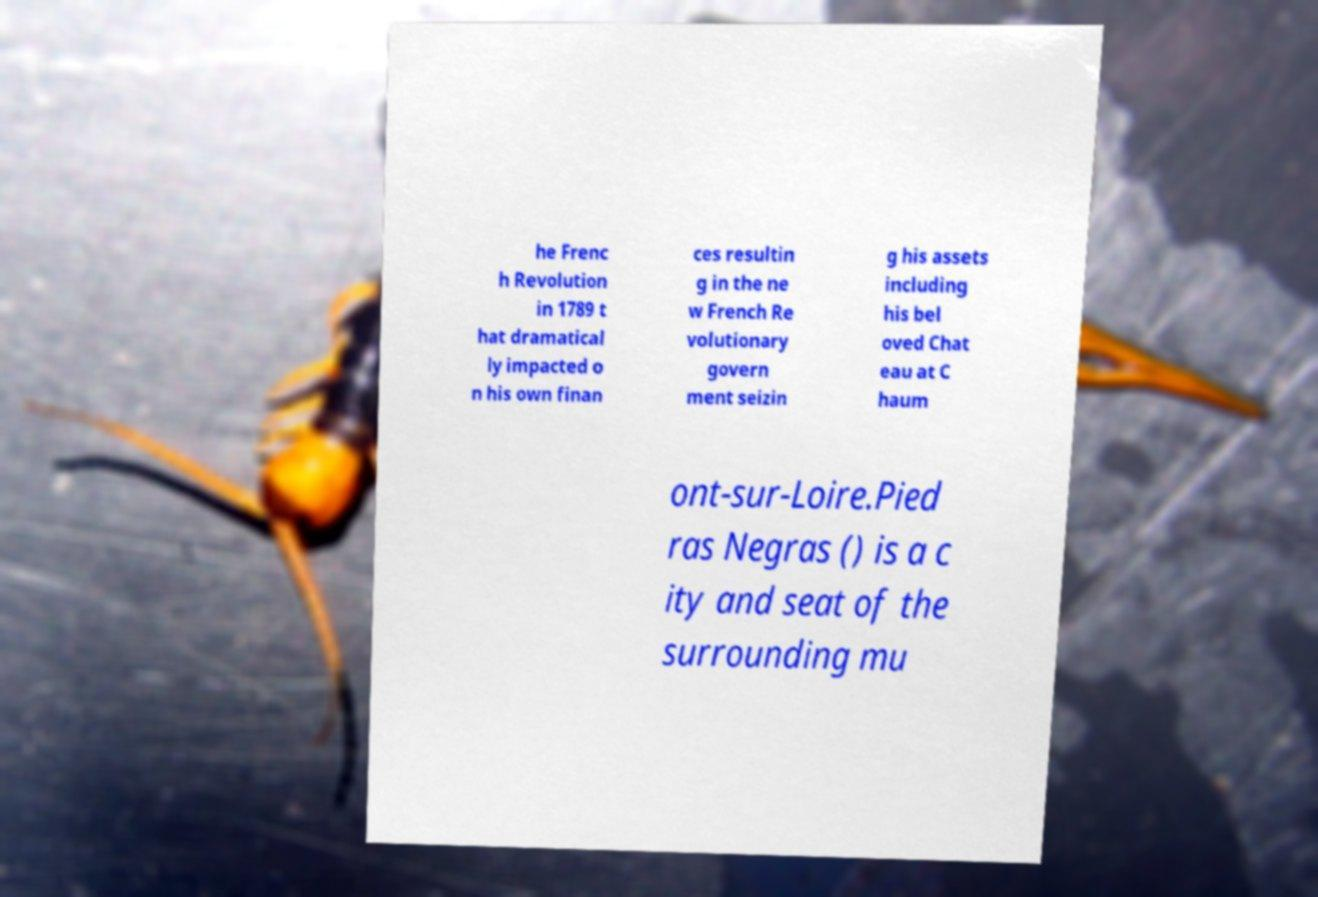Could you assist in decoding the text presented in this image and type it out clearly? he Frenc h Revolution in 1789 t hat dramatical ly impacted o n his own finan ces resultin g in the ne w French Re volutionary govern ment seizin g his assets including his bel oved Chat eau at C haum ont-sur-Loire.Pied ras Negras () is a c ity and seat of the surrounding mu 